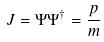<formula> <loc_0><loc_0><loc_500><loc_500>J = \Psi \Psi ^ { \dagger } = \frac { p } { m }</formula> 